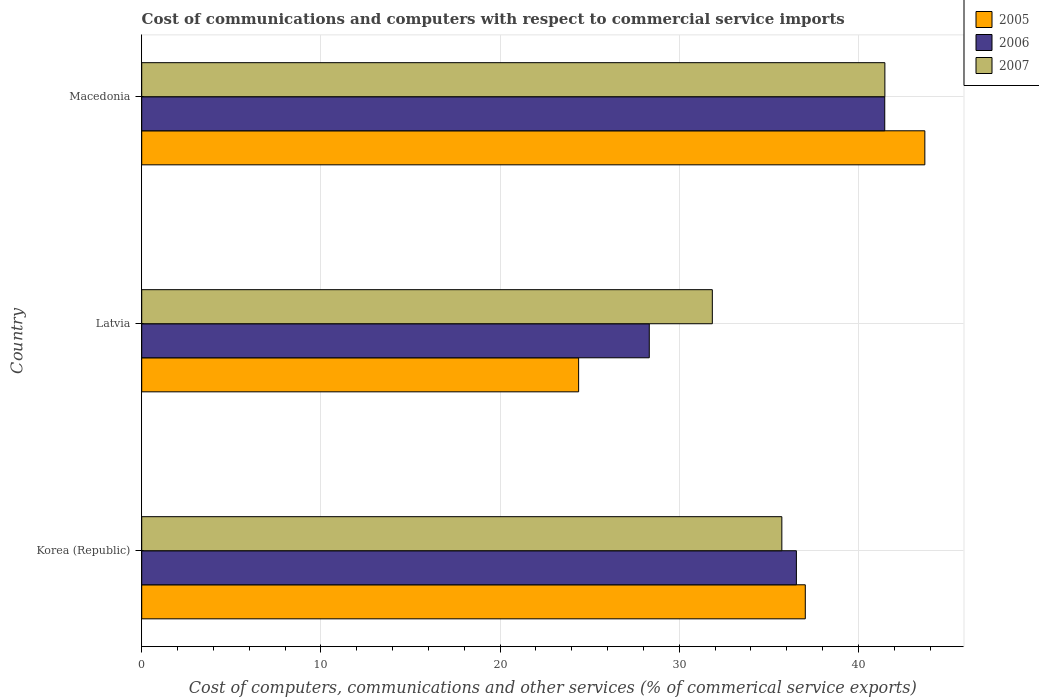Are the number of bars on each tick of the Y-axis equal?
Make the answer very short. Yes. How many bars are there on the 1st tick from the bottom?
Provide a succinct answer. 3. What is the label of the 2nd group of bars from the top?
Offer a very short reply. Latvia. What is the cost of communications and computers in 2007 in Korea (Republic)?
Offer a very short reply. 35.73. Across all countries, what is the maximum cost of communications and computers in 2007?
Provide a succinct answer. 41.48. Across all countries, what is the minimum cost of communications and computers in 2006?
Ensure brevity in your answer.  28.33. In which country was the cost of communications and computers in 2005 maximum?
Give a very brief answer. Macedonia. In which country was the cost of communications and computers in 2007 minimum?
Provide a short and direct response. Latvia. What is the total cost of communications and computers in 2005 in the graph?
Make the answer very short. 105.14. What is the difference between the cost of communications and computers in 2005 in Korea (Republic) and that in Latvia?
Your response must be concise. 12.65. What is the difference between the cost of communications and computers in 2005 in Macedonia and the cost of communications and computers in 2006 in Korea (Republic)?
Provide a short and direct response. 7.17. What is the average cost of communications and computers in 2005 per country?
Your answer should be compact. 35.05. What is the difference between the cost of communications and computers in 2005 and cost of communications and computers in 2006 in Korea (Republic)?
Make the answer very short. 0.5. What is the ratio of the cost of communications and computers in 2005 in Korea (Republic) to that in Latvia?
Your answer should be very brief. 1.52. Is the cost of communications and computers in 2005 in Latvia less than that in Macedonia?
Provide a short and direct response. Yes. Is the difference between the cost of communications and computers in 2005 in Korea (Republic) and Latvia greater than the difference between the cost of communications and computers in 2006 in Korea (Republic) and Latvia?
Ensure brevity in your answer.  Yes. What is the difference between the highest and the second highest cost of communications and computers in 2006?
Your answer should be compact. 4.93. What is the difference between the highest and the lowest cost of communications and computers in 2007?
Give a very brief answer. 9.63. In how many countries, is the cost of communications and computers in 2006 greater than the average cost of communications and computers in 2006 taken over all countries?
Provide a succinct answer. 2. What does the 3rd bar from the top in Latvia represents?
Provide a succinct answer. 2005. What does the 2nd bar from the bottom in Korea (Republic) represents?
Provide a succinct answer. 2006. Are all the bars in the graph horizontal?
Ensure brevity in your answer.  Yes. What is the difference between two consecutive major ticks on the X-axis?
Your answer should be very brief. 10. Does the graph contain grids?
Make the answer very short. Yes. How many legend labels are there?
Offer a very short reply. 3. What is the title of the graph?
Offer a very short reply. Cost of communications and computers with respect to commercial service imports. What is the label or title of the X-axis?
Your answer should be compact. Cost of computers, communications and other services (% of commerical service exports). What is the label or title of the Y-axis?
Provide a short and direct response. Country. What is the Cost of computers, communications and other services (% of commerical service exports) in 2005 in Korea (Republic)?
Your answer should be very brief. 37.04. What is the Cost of computers, communications and other services (% of commerical service exports) in 2006 in Korea (Republic)?
Your answer should be very brief. 36.54. What is the Cost of computers, communications and other services (% of commerical service exports) of 2007 in Korea (Republic)?
Your answer should be compact. 35.73. What is the Cost of computers, communications and other services (% of commerical service exports) in 2005 in Latvia?
Make the answer very short. 24.39. What is the Cost of computers, communications and other services (% of commerical service exports) in 2006 in Latvia?
Your answer should be compact. 28.33. What is the Cost of computers, communications and other services (% of commerical service exports) in 2007 in Latvia?
Ensure brevity in your answer.  31.85. What is the Cost of computers, communications and other services (% of commerical service exports) in 2005 in Macedonia?
Your response must be concise. 43.71. What is the Cost of computers, communications and other services (% of commerical service exports) in 2006 in Macedonia?
Ensure brevity in your answer.  41.47. What is the Cost of computers, communications and other services (% of commerical service exports) of 2007 in Macedonia?
Ensure brevity in your answer.  41.48. Across all countries, what is the maximum Cost of computers, communications and other services (% of commerical service exports) of 2005?
Your response must be concise. 43.71. Across all countries, what is the maximum Cost of computers, communications and other services (% of commerical service exports) in 2006?
Your response must be concise. 41.47. Across all countries, what is the maximum Cost of computers, communications and other services (% of commerical service exports) in 2007?
Provide a succinct answer. 41.48. Across all countries, what is the minimum Cost of computers, communications and other services (% of commerical service exports) of 2005?
Your answer should be compact. 24.39. Across all countries, what is the minimum Cost of computers, communications and other services (% of commerical service exports) of 2006?
Your answer should be compact. 28.33. Across all countries, what is the minimum Cost of computers, communications and other services (% of commerical service exports) in 2007?
Keep it short and to the point. 31.85. What is the total Cost of computers, communications and other services (% of commerical service exports) in 2005 in the graph?
Ensure brevity in your answer.  105.14. What is the total Cost of computers, communications and other services (% of commerical service exports) in 2006 in the graph?
Your answer should be compact. 106.35. What is the total Cost of computers, communications and other services (% of commerical service exports) of 2007 in the graph?
Give a very brief answer. 109.06. What is the difference between the Cost of computers, communications and other services (% of commerical service exports) in 2005 in Korea (Republic) and that in Latvia?
Keep it short and to the point. 12.65. What is the difference between the Cost of computers, communications and other services (% of commerical service exports) in 2006 in Korea (Republic) and that in Latvia?
Ensure brevity in your answer.  8.21. What is the difference between the Cost of computers, communications and other services (% of commerical service exports) in 2007 in Korea (Republic) and that in Latvia?
Keep it short and to the point. 3.88. What is the difference between the Cost of computers, communications and other services (% of commerical service exports) of 2005 in Korea (Republic) and that in Macedonia?
Your response must be concise. -6.67. What is the difference between the Cost of computers, communications and other services (% of commerical service exports) of 2006 in Korea (Republic) and that in Macedonia?
Offer a very short reply. -4.93. What is the difference between the Cost of computers, communications and other services (% of commerical service exports) of 2007 in Korea (Republic) and that in Macedonia?
Offer a terse response. -5.75. What is the difference between the Cost of computers, communications and other services (% of commerical service exports) of 2005 in Latvia and that in Macedonia?
Offer a very short reply. -19.32. What is the difference between the Cost of computers, communications and other services (% of commerical service exports) in 2006 in Latvia and that in Macedonia?
Your response must be concise. -13.14. What is the difference between the Cost of computers, communications and other services (% of commerical service exports) of 2007 in Latvia and that in Macedonia?
Provide a short and direct response. -9.63. What is the difference between the Cost of computers, communications and other services (% of commerical service exports) in 2005 in Korea (Republic) and the Cost of computers, communications and other services (% of commerical service exports) in 2006 in Latvia?
Make the answer very short. 8.71. What is the difference between the Cost of computers, communications and other services (% of commerical service exports) in 2005 in Korea (Republic) and the Cost of computers, communications and other services (% of commerical service exports) in 2007 in Latvia?
Provide a short and direct response. 5.19. What is the difference between the Cost of computers, communications and other services (% of commerical service exports) of 2006 in Korea (Republic) and the Cost of computers, communications and other services (% of commerical service exports) of 2007 in Latvia?
Provide a short and direct response. 4.69. What is the difference between the Cost of computers, communications and other services (% of commerical service exports) of 2005 in Korea (Republic) and the Cost of computers, communications and other services (% of commerical service exports) of 2006 in Macedonia?
Keep it short and to the point. -4.43. What is the difference between the Cost of computers, communications and other services (% of commerical service exports) of 2005 in Korea (Republic) and the Cost of computers, communications and other services (% of commerical service exports) of 2007 in Macedonia?
Offer a terse response. -4.44. What is the difference between the Cost of computers, communications and other services (% of commerical service exports) of 2006 in Korea (Republic) and the Cost of computers, communications and other services (% of commerical service exports) of 2007 in Macedonia?
Offer a very short reply. -4.94. What is the difference between the Cost of computers, communications and other services (% of commerical service exports) of 2005 in Latvia and the Cost of computers, communications and other services (% of commerical service exports) of 2006 in Macedonia?
Offer a very short reply. -17.09. What is the difference between the Cost of computers, communications and other services (% of commerical service exports) in 2005 in Latvia and the Cost of computers, communications and other services (% of commerical service exports) in 2007 in Macedonia?
Your answer should be very brief. -17.09. What is the difference between the Cost of computers, communications and other services (% of commerical service exports) of 2006 in Latvia and the Cost of computers, communications and other services (% of commerical service exports) of 2007 in Macedonia?
Keep it short and to the point. -13.15. What is the average Cost of computers, communications and other services (% of commerical service exports) in 2005 per country?
Make the answer very short. 35.05. What is the average Cost of computers, communications and other services (% of commerical service exports) in 2006 per country?
Give a very brief answer. 35.45. What is the average Cost of computers, communications and other services (% of commerical service exports) of 2007 per country?
Your response must be concise. 36.35. What is the difference between the Cost of computers, communications and other services (% of commerical service exports) of 2005 and Cost of computers, communications and other services (% of commerical service exports) of 2006 in Korea (Republic)?
Offer a very short reply. 0.5. What is the difference between the Cost of computers, communications and other services (% of commerical service exports) of 2005 and Cost of computers, communications and other services (% of commerical service exports) of 2007 in Korea (Republic)?
Offer a terse response. 1.31. What is the difference between the Cost of computers, communications and other services (% of commerical service exports) in 2006 and Cost of computers, communications and other services (% of commerical service exports) in 2007 in Korea (Republic)?
Give a very brief answer. 0.81. What is the difference between the Cost of computers, communications and other services (% of commerical service exports) in 2005 and Cost of computers, communications and other services (% of commerical service exports) in 2006 in Latvia?
Your answer should be very brief. -3.94. What is the difference between the Cost of computers, communications and other services (% of commerical service exports) in 2005 and Cost of computers, communications and other services (% of commerical service exports) in 2007 in Latvia?
Provide a short and direct response. -7.46. What is the difference between the Cost of computers, communications and other services (% of commerical service exports) in 2006 and Cost of computers, communications and other services (% of commerical service exports) in 2007 in Latvia?
Your answer should be compact. -3.52. What is the difference between the Cost of computers, communications and other services (% of commerical service exports) of 2005 and Cost of computers, communications and other services (% of commerical service exports) of 2006 in Macedonia?
Your answer should be very brief. 2.24. What is the difference between the Cost of computers, communications and other services (% of commerical service exports) in 2005 and Cost of computers, communications and other services (% of commerical service exports) in 2007 in Macedonia?
Provide a short and direct response. 2.23. What is the difference between the Cost of computers, communications and other services (% of commerical service exports) of 2006 and Cost of computers, communications and other services (% of commerical service exports) of 2007 in Macedonia?
Provide a short and direct response. -0.01. What is the ratio of the Cost of computers, communications and other services (% of commerical service exports) of 2005 in Korea (Republic) to that in Latvia?
Offer a terse response. 1.52. What is the ratio of the Cost of computers, communications and other services (% of commerical service exports) of 2006 in Korea (Republic) to that in Latvia?
Your answer should be compact. 1.29. What is the ratio of the Cost of computers, communications and other services (% of commerical service exports) in 2007 in Korea (Republic) to that in Latvia?
Give a very brief answer. 1.12. What is the ratio of the Cost of computers, communications and other services (% of commerical service exports) in 2005 in Korea (Republic) to that in Macedonia?
Your answer should be compact. 0.85. What is the ratio of the Cost of computers, communications and other services (% of commerical service exports) in 2006 in Korea (Republic) to that in Macedonia?
Provide a short and direct response. 0.88. What is the ratio of the Cost of computers, communications and other services (% of commerical service exports) in 2007 in Korea (Republic) to that in Macedonia?
Your answer should be very brief. 0.86. What is the ratio of the Cost of computers, communications and other services (% of commerical service exports) of 2005 in Latvia to that in Macedonia?
Your answer should be very brief. 0.56. What is the ratio of the Cost of computers, communications and other services (% of commerical service exports) in 2006 in Latvia to that in Macedonia?
Provide a short and direct response. 0.68. What is the ratio of the Cost of computers, communications and other services (% of commerical service exports) in 2007 in Latvia to that in Macedonia?
Ensure brevity in your answer.  0.77. What is the difference between the highest and the second highest Cost of computers, communications and other services (% of commerical service exports) of 2005?
Ensure brevity in your answer.  6.67. What is the difference between the highest and the second highest Cost of computers, communications and other services (% of commerical service exports) in 2006?
Give a very brief answer. 4.93. What is the difference between the highest and the second highest Cost of computers, communications and other services (% of commerical service exports) of 2007?
Offer a terse response. 5.75. What is the difference between the highest and the lowest Cost of computers, communications and other services (% of commerical service exports) in 2005?
Keep it short and to the point. 19.32. What is the difference between the highest and the lowest Cost of computers, communications and other services (% of commerical service exports) in 2006?
Provide a succinct answer. 13.14. What is the difference between the highest and the lowest Cost of computers, communications and other services (% of commerical service exports) in 2007?
Offer a very short reply. 9.63. 